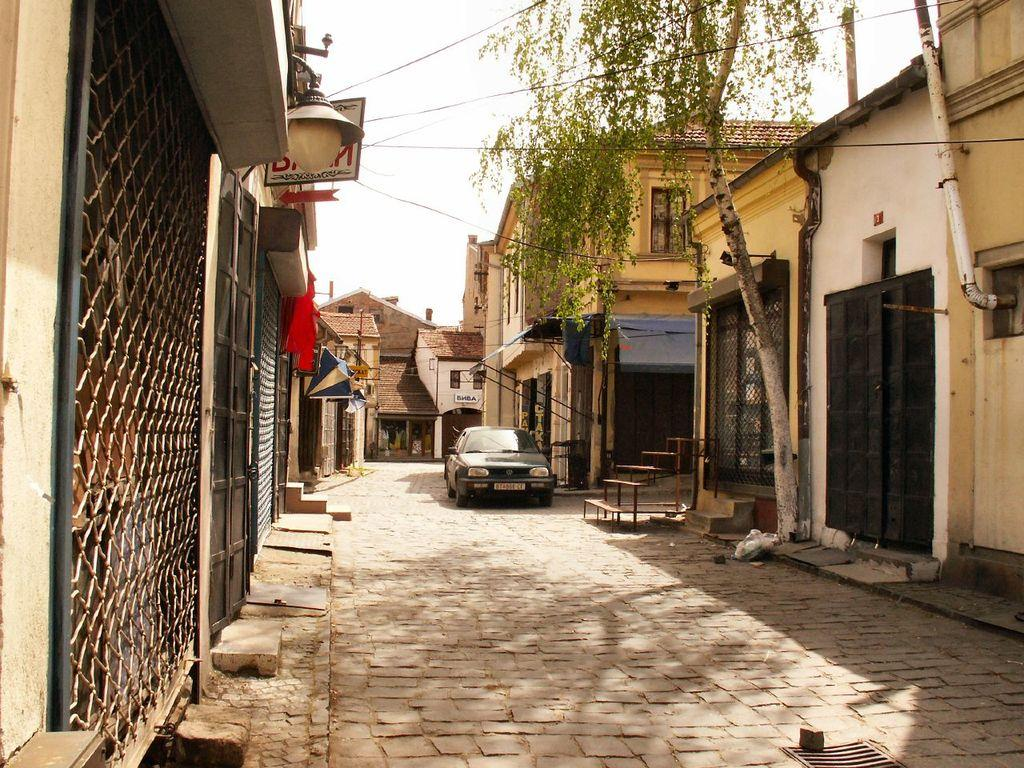What is parked on the road in the image? There is a car parked on the road in the image. What can be seen on either side of the car? There are houses to the left and right of the car. What type of vegetation is near the car? There is a tree to the right of the car. What is visible at the top of the image? The sky is visible at the top of the image. What is visible at the bottom of the image? The road is visible at the bottom of the image. What type of carpentry work is being done in the scene? There is no carpentry work or carpenter present in the image. How are the houses and car joined together in the image? The houses and car are not joined together in the image; they are separate structures. 